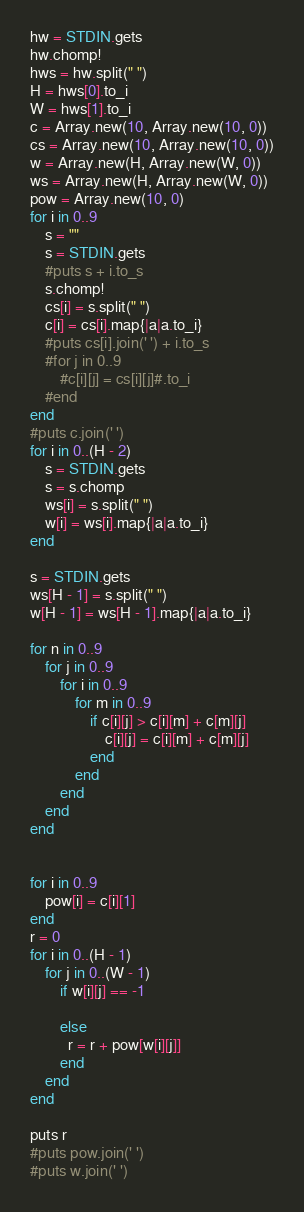Convert code to text. <code><loc_0><loc_0><loc_500><loc_500><_Ruby_>hw = STDIN.gets
hw.chomp!
hws = hw.split(" ")
H = hws[0].to_i
W = hws[1].to_i
c = Array.new(10, Array.new(10, 0))
cs = Array.new(10, Array.new(10, 0))
w = Array.new(H, Array.new(W, 0))
ws = Array.new(H, Array.new(W, 0))
pow = Array.new(10, 0)
for i in 0..9
  	s = ""
	s = STDIN.gets
  	#puts s + i.to_s
	s.chomp!
	cs[i] = s.split(" ")
  	c[i] = cs[i].map{|a|a.to_i}
  	#puts cs[i].join(' ') + i.to_s
	#for j in 0..9
		#c[i][j] = cs[i][j]#.to_i
	#end
end
#puts c.join(' ')
for i in 0..(H - 2)
	s = STDIN.gets
	s = s.chomp
	ws[i] = s.split(" ")
    w[i] = ws[i].map{|a|a.to_i}
end

s = STDIN.gets
ws[H - 1] = s.split(" ")
w[H - 1] = ws[H - 1].map{|a|a.to_i}

for n in 0..9
	for j in 0..9
		for i in 0..9
			for m in 0..9
				if c[i][j] > c[i][m] + c[m][j]
					c[i][j] = c[i][m] + c[m][j]
				end
			end
		end
	end
end


for i in 0..9
	pow[i] = c[i][1]
end
r = 0
for i in 0..(H - 1)
	for j in 0..(W - 1)
      	if w[i][j] == -1
          
        else
		  r = r + pow[w[i][j]]
        end
	end
end

puts r
#puts pow.join(' ')
#puts w.join(' ')</code> 